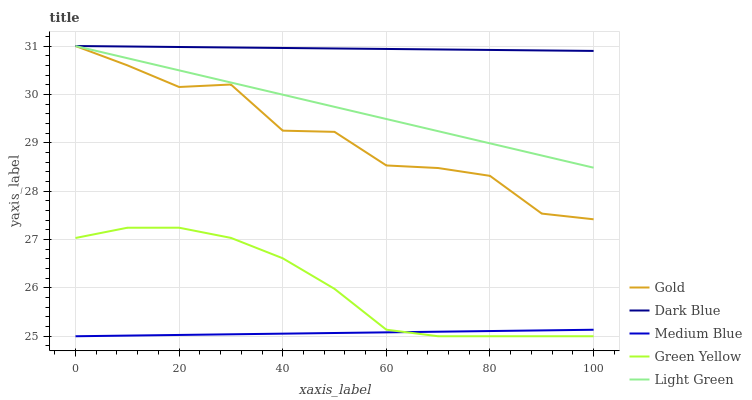Does Medium Blue have the minimum area under the curve?
Answer yes or no. Yes. Does Dark Blue have the maximum area under the curve?
Answer yes or no. Yes. Does Green Yellow have the minimum area under the curve?
Answer yes or no. No. Does Green Yellow have the maximum area under the curve?
Answer yes or no. No. Is Light Green the smoothest?
Answer yes or no. Yes. Is Gold the roughest?
Answer yes or no. Yes. Is Green Yellow the smoothest?
Answer yes or no. No. Is Green Yellow the roughest?
Answer yes or no. No. Does Green Yellow have the lowest value?
Answer yes or no. Yes. Does Light Green have the lowest value?
Answer yes or no. No. Does Gold have the highest value?
Answer yes or no. Yes. Does Green Yellow have the highest value?
Answer yes or no. No. Is Green Yellow less than Gold?
Answer yes or no. Yes. Is Light Green greater than Medium Blue?
Answer yes or no. Yes. Does Gold intersect Light Green?
Answer yes or no. Yes. Is Gold less than Light Green?
Answer yes or no. No. Is Gold greater than Light Green?
Answer yes or no. No. Does Green Yellow intersect Gold?
Answer yes or no. No. 